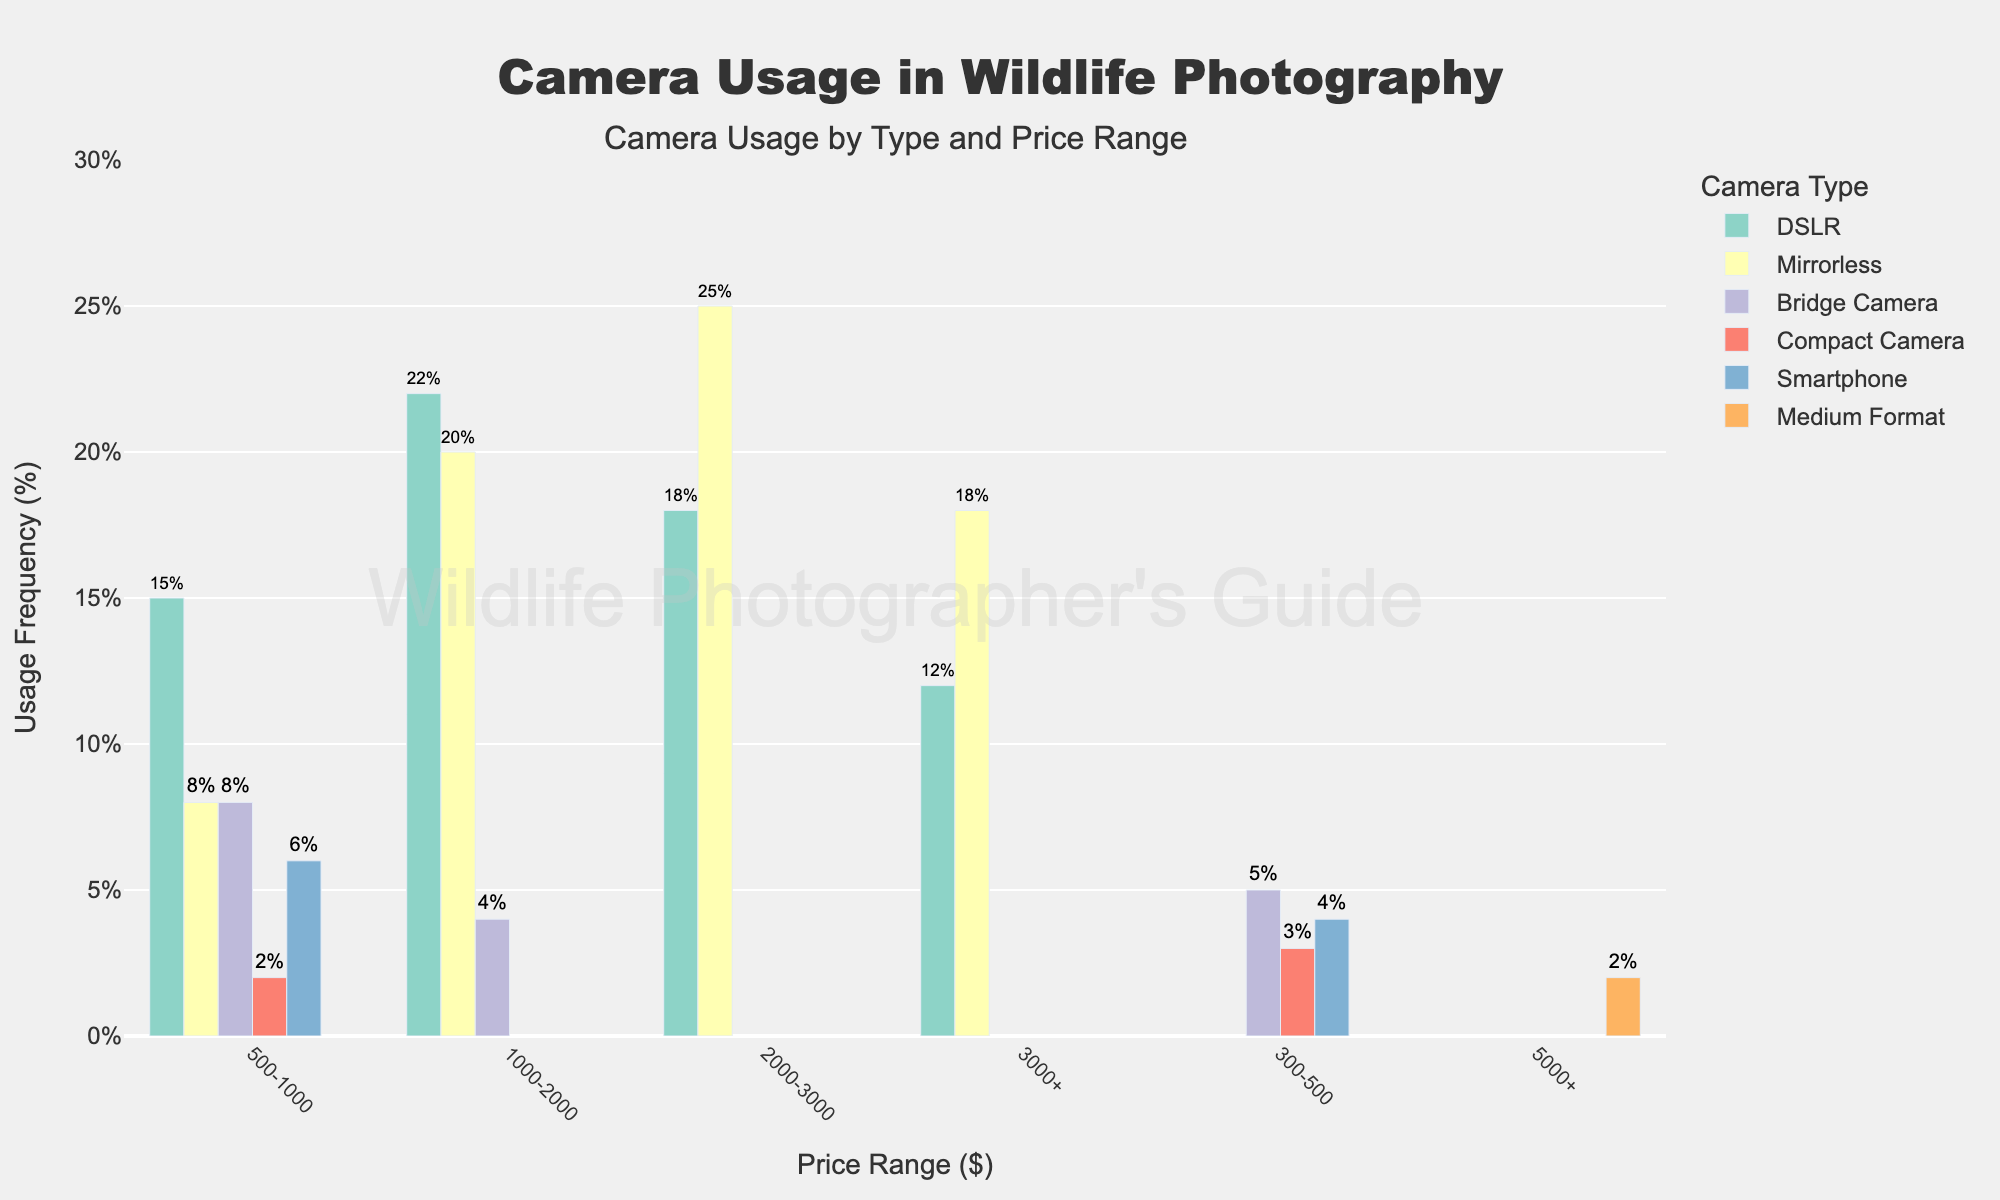Which camera type has the highest usage frequency in the 2000-3000 price range? To find the camera type with the highest usage frequency in the 2000-3000 price range, we look at the bar heights or hover text for that range. DSLR has a frequency of 18%, while Mirrorless has a frequency of 25%.
Answer: Mirrorless In which price range does the Bridge Camera type have the lowest usage frequency? By examining the bar heights for Bridge Camera across different price ranges, we see the bars for 300-500, 500-1000, and 1000-2000. The lowest usage frequency is in the 1000-2000 range at 4%.
Answer: 1000-2000 What is the total usage frequency for DSLR cameras over all price ranges? Sum up the usage frequency for DSLR cameras across all price ranges: 15% (500-1000) + 22% (1000-2000) + 18% (2000-3000) + 12% (3000+). The total is 15 + 22 + 18 + 12 = 67%.
Answer: 67% Which camera type under the price range 1000-2000 has a higher usage frequency, Mirrorless or DSLR? Compare the usage frequencies of Mirrorless and DSLR within the price range of 1000-2000. DSLR has a frequency of 22%, while Mirrorless has a frequency of 20%. Since 22% > 20%, DSLR has a higher usage frequency.
Answer: DSLR Which price range has the lowest overall usage frequency across all camera types? Sum up the usage frequencies for all camera types within each price range and compare them. For instance, 300-500 has (Bridge Camera 5%, Compact Camera 3%, Smartphone 4%) totaling 12%. Repeat for other price ranges and find the one with the lowest sum. The 1000-2000 range has (DSLR 22%, Mirrorless 20%, Bridge Camera 4%) which is 46%, and so on. The 1000-2000 range with a sum of 46% is the lowest.
Answer: 1000-2000 